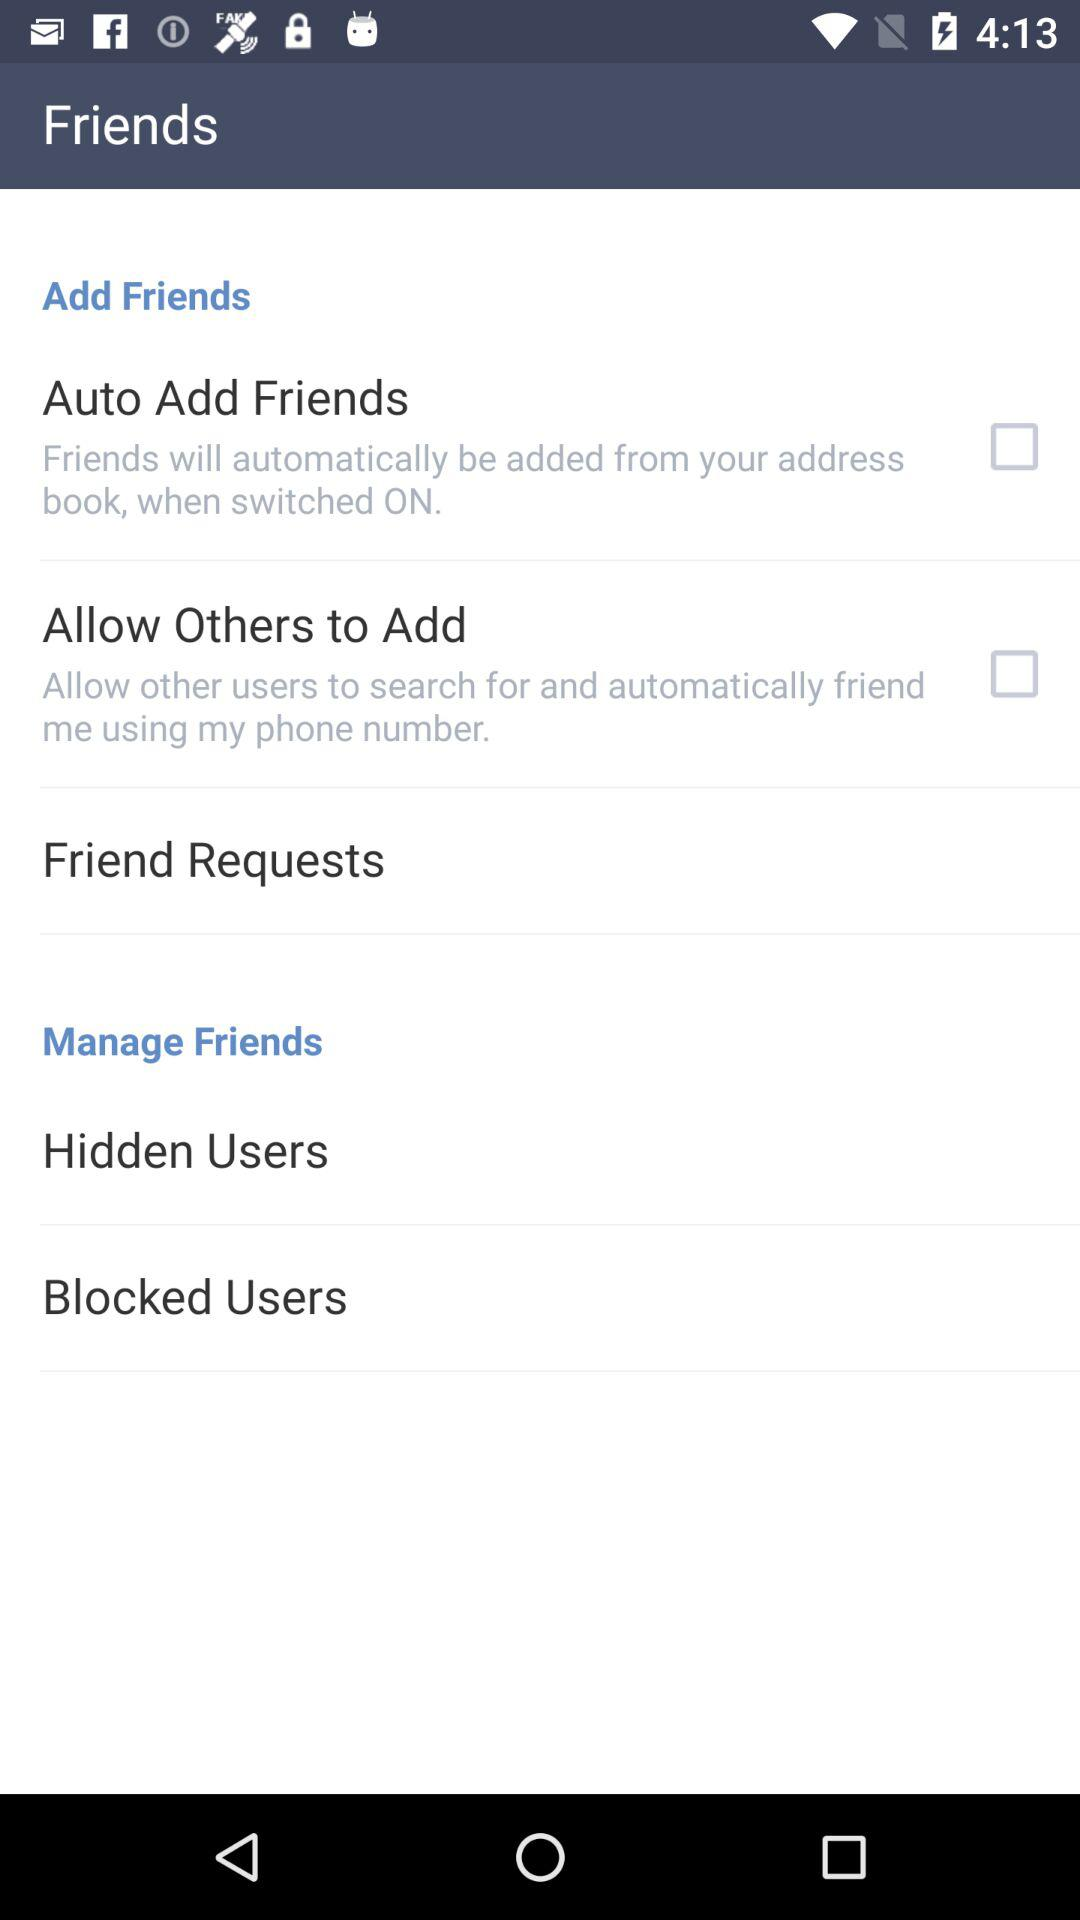How many items are in the Friends section that have a checkbox?
Answer the question using a single word or phrase. 2 